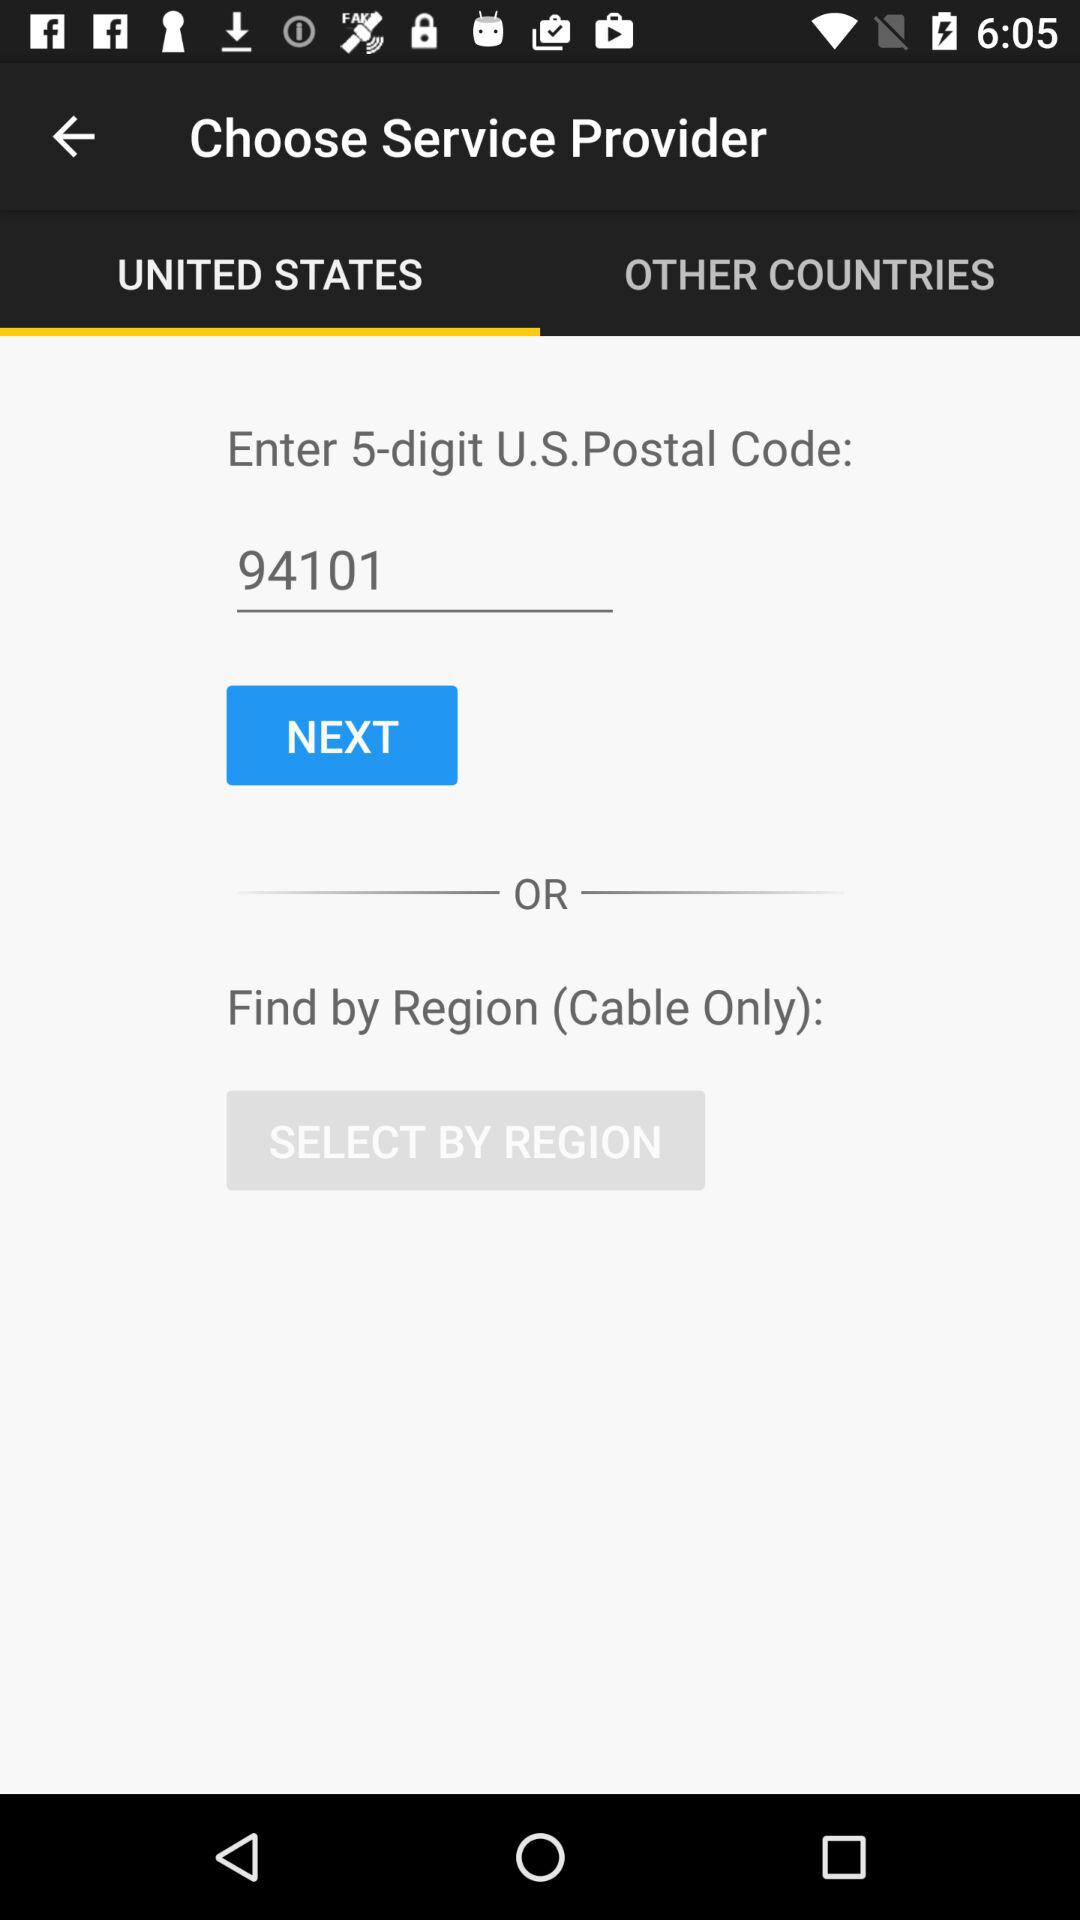What is the 5-digit U.S. postal code? The 5-digit U.S. postal code is 94101. 